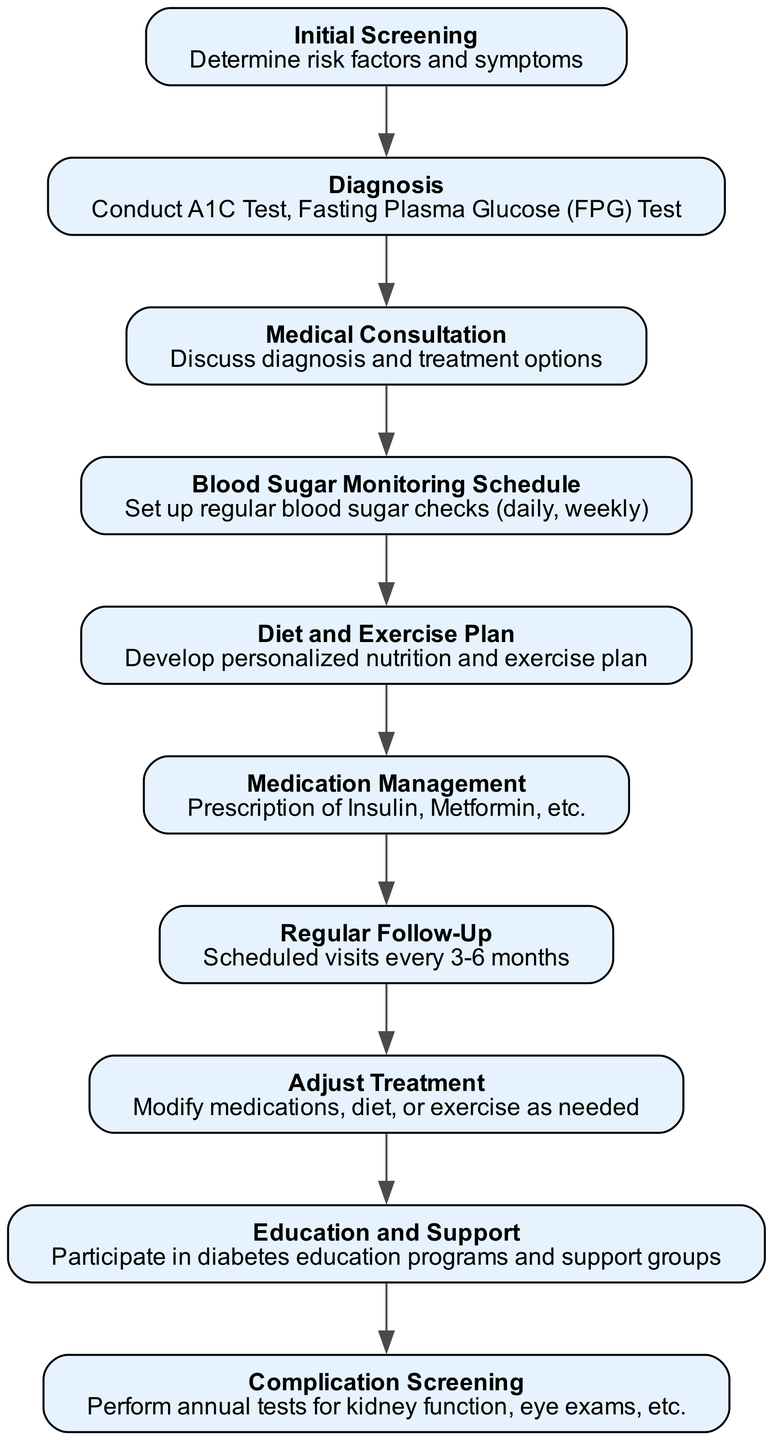What is the first step in the Diabetes Management Pathway? The first step is "Initial Screening," which focuses on determining risk factors and symptoms related to diabetes. This is evident as the first node listed in the diagram.
Answer: Initial Screening How many total nodes are there in the pathway? By counting the elements within the diagram, there are 10 nodes representing different steps in the diabetes management pathway.
Answer: 10 Which node follows "Medical Consultation"? The node following "Medical Consultation" is "Blood Sugar Monitoring Schedule," indicating the next step in the clinical pathway after discussing diagnosis and treatment options.
Answer: Blood Sugar Monitoring Schedule What is the main focus of the "Adjust Treatment" node? The "Adjust Treatment" node focuses on modifying medications, diet, or exercise based on the individual's needs and responses, integrating various aspects of the pathway.
Answer: Modify medications, diet, or exercise Which node performs complications screening and what does it entail? The "Complication Screening" node involves performing annual tests for kidney function and eye exams, relevant for managing diabetes-related complications.
Answer: Annual tests for kidney function, eye exams What is the schedule for "Regular Follow-Up"? The schedule for "Regular Follow-Up" specifies visits every 3-6 months, highlighting the importance of ongoing management and monitoring in diabetes care.
Answer: Every 3-6 months How does "Education and Support" contribute to the pathway? "Education and Support" node emphasizes participating in diabetes education programs and support groups, which are essential for patient knowledge and encouragement in management.
Answer: Participate in education programs and support groups What happens after the "Blood Sugar Monitoring Schedule"? After "Blood Sugar Monitoring Schedule," the pathway leads to "Diet and Exercise Plan," showing the connection between monitoring results and lifestyle adjustments.
Answer: Diet and Exercise Plan 